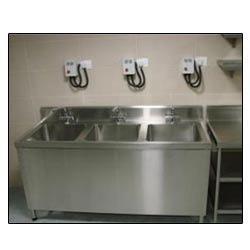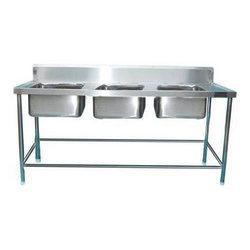The first image is the image on the left, the second image is the image on the right. Evaluate the accuracy of this statement regarding the images: "There are three faucets.". Is it true? Answer yes or no. Yes. The first image is the image on the left, the second image is the image on the right. Analyze the images presented: Is the assertion "IN at least one image there is a square white water basin on top of a dark wooden shelve." valid? Answer yes or no. No. 